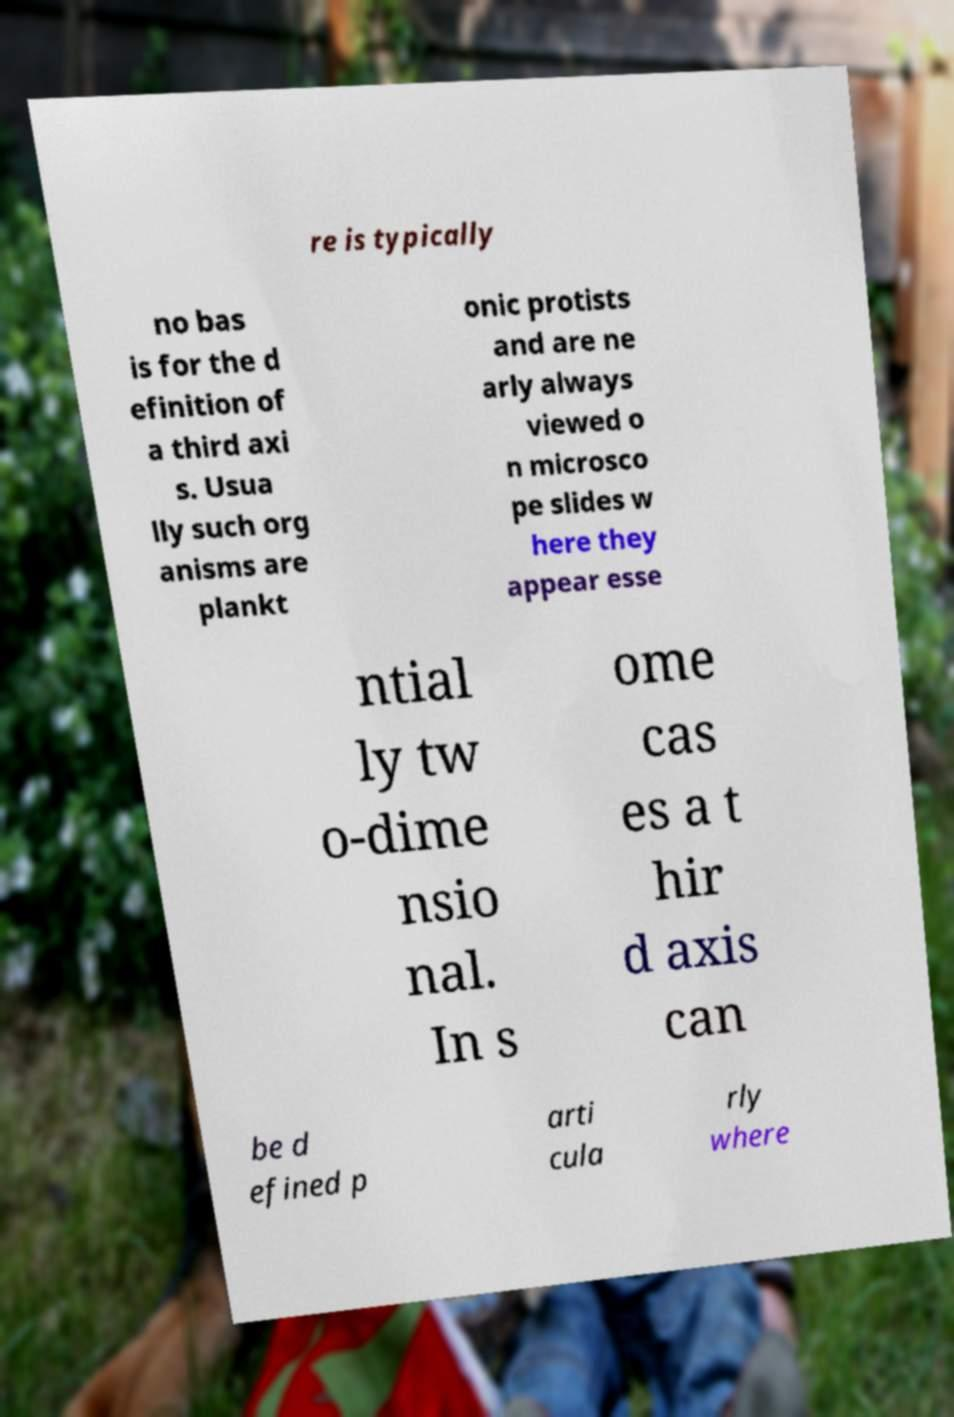Can you read and provide the text displayed in the image?This photo seems to have some interesting text. Can you extract and type it out for me? re is typically no bas is for the d efinition of a third axi s. Usua lly such org anisms are plankt onic protists and are ne arly always viewed o n microsco pe slides w here they appear esse ntial ly tw o-dime nsio nal. In s ome cas es a t hir d axis can be d efined p arti cula rly where 